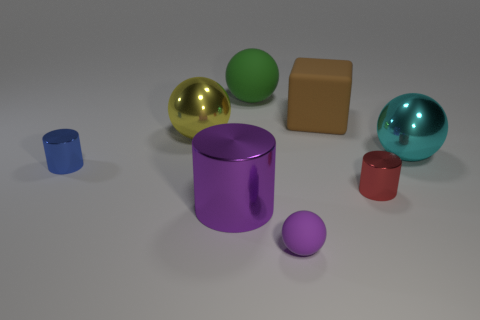What number of red cubes are there?
Your response must be concise. 0. What number of cylinders are either brown things or purple rubber things?
Give a very brief answer. 0. There is a ball behind the big yellow metallic object; how many big matte blocks are to the right of it?
Provide a short and direct response. 1. Are the small blue cylinder and the big yellow sphere made of the same material?
Give a very brief answer. Yes. The cylinder that is the same color as the small sphere is what size?
Your response must be concise. Large. Are there any big red cylinders made of the same material as the yellow object?
Keep it short and to the point. No. There is a large ball in front of the shiny ball to the left of the large metal ball that is to the right of the tiny purple rubber sphere; what is its color?
Offer a terse response. Cyan. How many yellow objects are metal balls or large cubes?
Provide a succinct answer. 1. What number of other small things have the same shape as the cyan object?
Your response must be concise. 1. The green object that is the same size as the purple cylinder is what shape?
Your response must be concise. Sphere. 